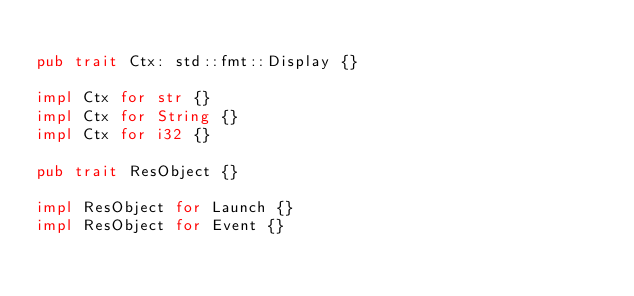<code> <loc_0><loc_0><loc_500><loc_500><_Rust_>
pub trait Ctx: std::fmt::Display {}

impl Ctx for str {}
impl Ctx for String {}
impl Ctx for i32 {}

pub trait ResObject {}

impl ResObject for Launch {}
impl ResObject for Event {}
</code> 